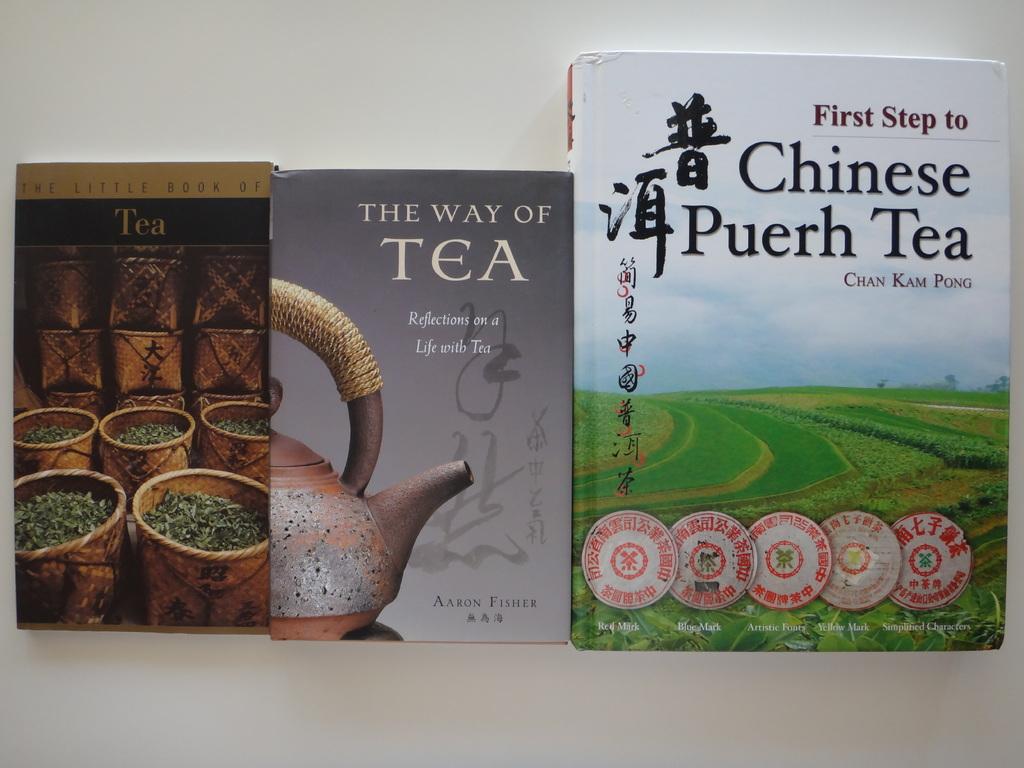The way of what?
Your response must be concise. Tea. What is the subject of the books?
Your answer should be very brief. Tea. 